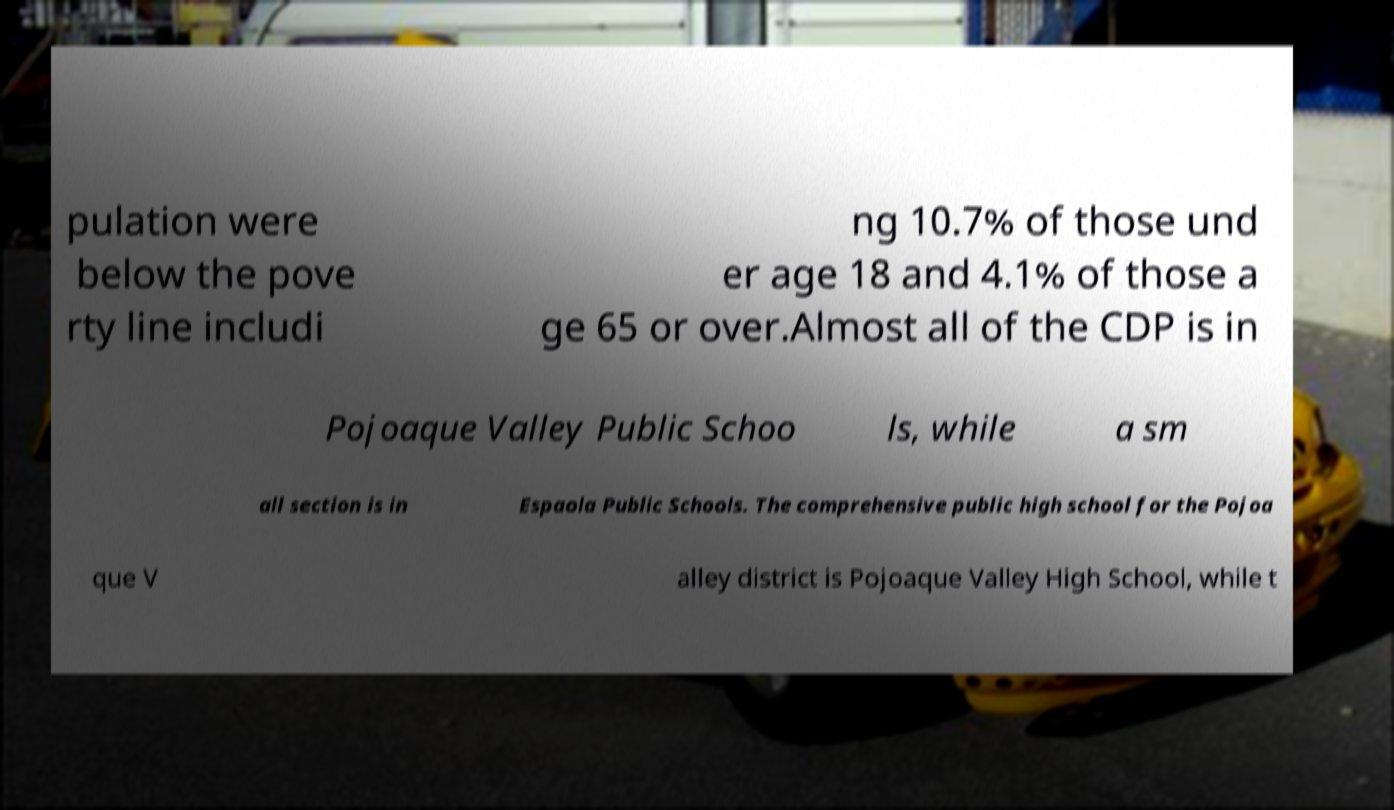There's text embedded in this image that I need extracted. Can you transcribe it verbatim? pulation were below the pove rty line includi ng 10.7% of those und er age 18 and 4.1% of those a ge 65 or over.Almost all of the CDP is in Pojoaque Valley Public Schoo ls, while a sm all section is in Espaola Public Schools. The comprehensive public high school for the Pojoa que V alley district is Pojoaque Valley High School, while t 